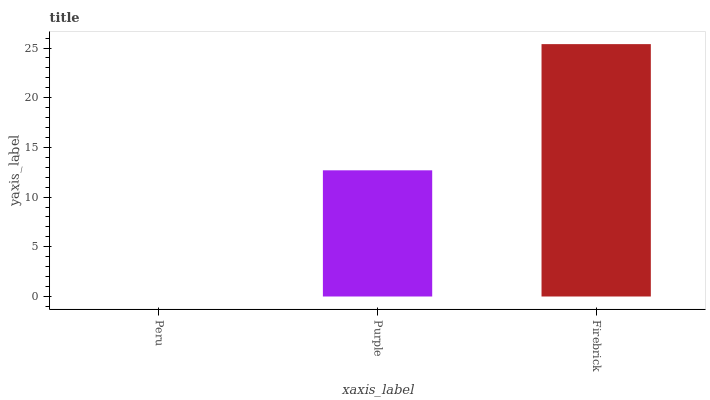Is Peru the minimum?
Answer yes or no. Yes. Is Firebrick the maximum?
Answer yes or no. Yes. Is Purple the minimum?
Answer yes or no. No. Is Purple the maximum?
Answer yes or no. No. Is Purple greater than Peru?
Answer yes or no. Yes. Is Peru less than Purple?
Answer yes or no. Yes. Is Peru greater than Purple?
Answer yes or no. No. Is Purple less than Peru?
Answer yes or no. No. Is Purple the high median?
Answer yes or no. Yes. Is Purple the low median?
Answer yes or no. Yes. Is Firebrick the high median?
Answer yes or no. No. Is Firebrick the low median?
Answer yes or no. No. 